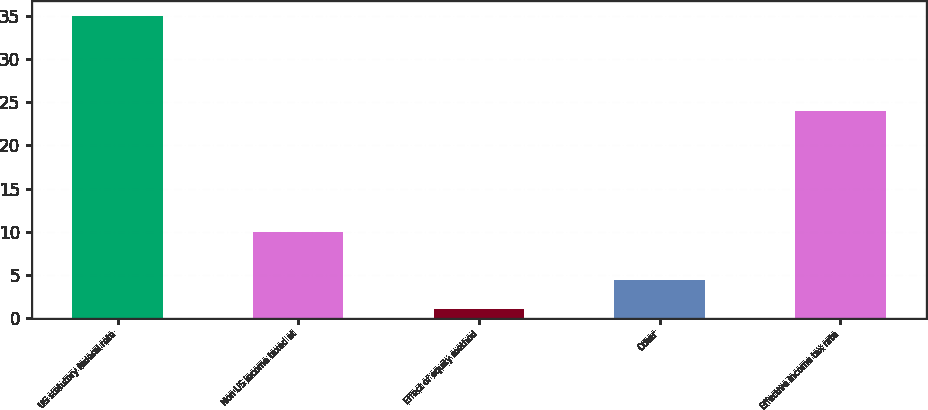Convert chart. <chart><loc_0><loc_0><loc_500><loc_500><bar_chart><fcel>US statutory federal rate<fcel>Non US income taxed at<fcel>Effect of equity method<fcel>Other<fcel>Effective income tax rate<nl><fcel>35<fcel>10<fcel>1<fcel>4.4<fcel>24<nl></chart> 